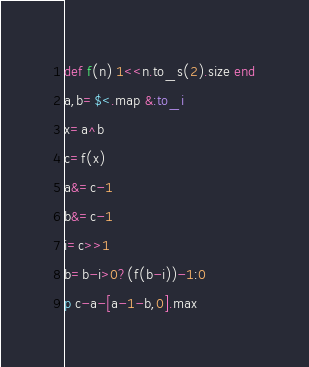<code> <loc_0><loc_0><loc_500><loc_500><_Ruby_>def f(n) 1<<n.to_s(2).size end
a,b=$<.map &:to_i
x=a^b
c=f(x)
a&=c-1
b&=c-1
i=c>>1
b=b-i>0?(f(b-i))-1:0
p c-a-[a-1-b,0].max</code> 